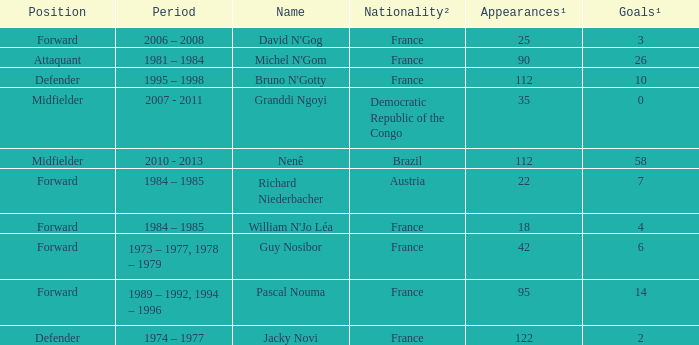List the number of active years for attaquant. 1981 – 1984. Can you give me this table as a dict? {'header': ['Position', 'Period', 'Name', 'Nationality²', 'Appearances¹', 'Goals¹'], 'rows': [['Forward', '2006 – 2008', "David N'Gog", 'France', '25', '3'], ['Attaquant', '1981 – 1984', "Michel N'Gom", 'France', '90', '26'], ['Defender', '1995 – 1998', "Bruno N'Gotty", 'France', '112', '10'], ['Midfielder', '2007 - 2011', 'Granddi Ngoyi', 'Democratic Republic of the Congo', '35', '0'], ['Midfielder', '2010 - 2013', 'Nenê', 'Brazil', '112', '58'], ['Forward', '1984 – 1985', 'Richard Niederbacher', 'Austria', '22', '7'], ['Forward', '1984 – 1985', "William N'Jo Léa", 'France', '18', '4'], ['Forward', '1973 – 1977, 1978 – 1979', 'Guy Nosibor', 'France', '42', '6'], ['Forward', '1989 – 1992, 1994 – 1996', 'Pascal Nouma', 'France', '95', '14'], ['Defender', '1974 – 1977', 'Jacky Novi', 'France', '122', '2']]} 